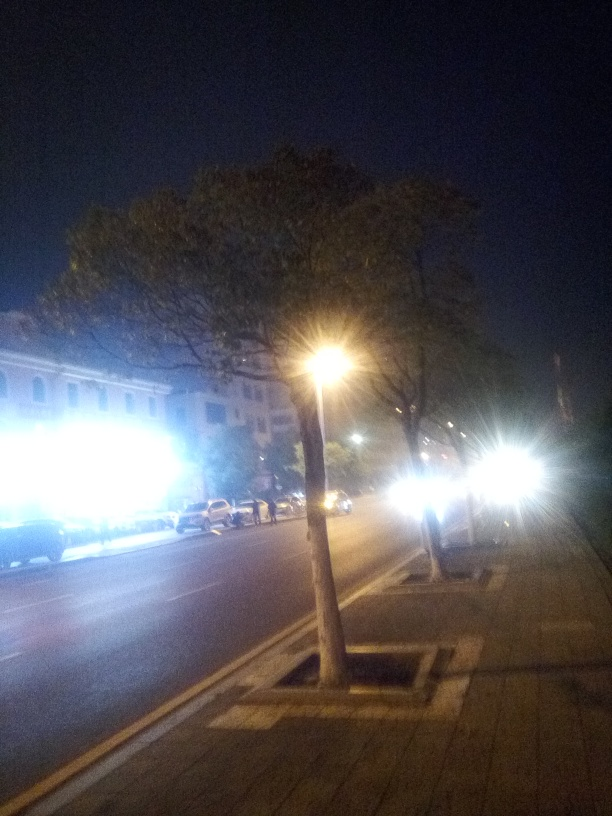Describe the location this image is taken. Does it look busy? The image captures a street scene at night, characterized by parked cars and a light stream of traffic, illuminated by streetlights. The presence of vehicles suggests moderate activity, but it doesn't appear to be particularly busy, possibly due to the time of day. 